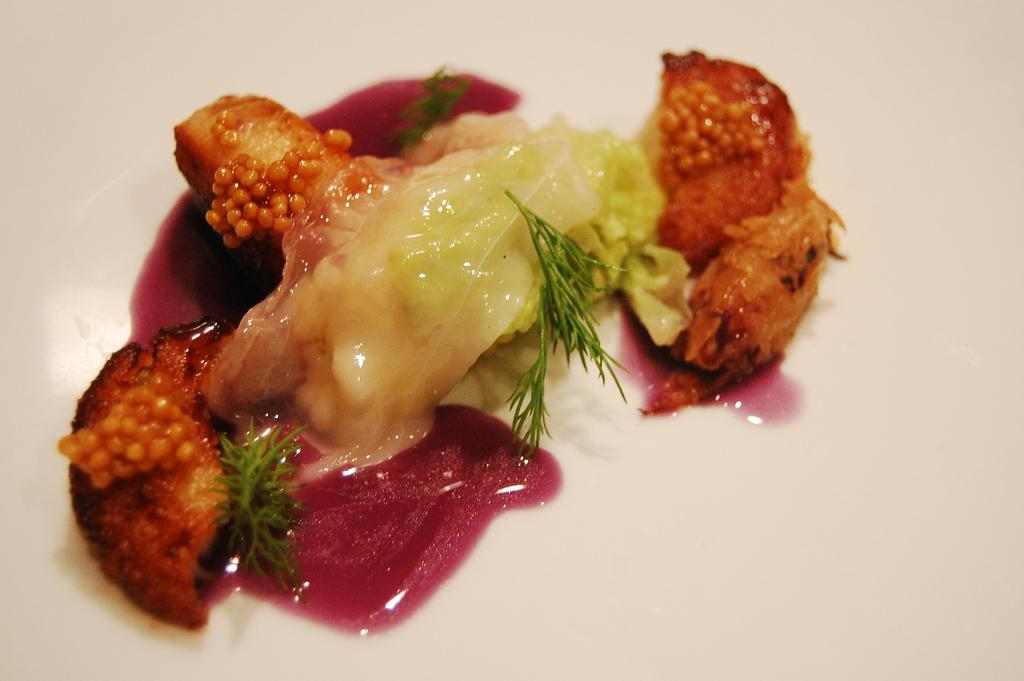What is present in the image that can be eaten? There is food visible in the image. Where is the food located? The food is on a surface. Can you see any chalk drawings near the lake in the image? There is no lake or chalk drawings present in the image. How many hands are visible holding the food in the image? There is no hand visible holding the food in the image. 